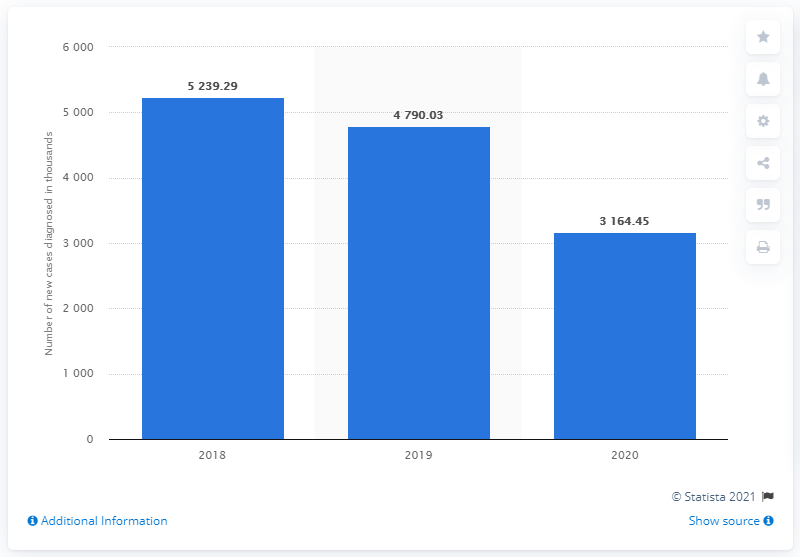Specify some key components in this picture. In 2018, the highest number of influenza cases was recorded in Poland. 